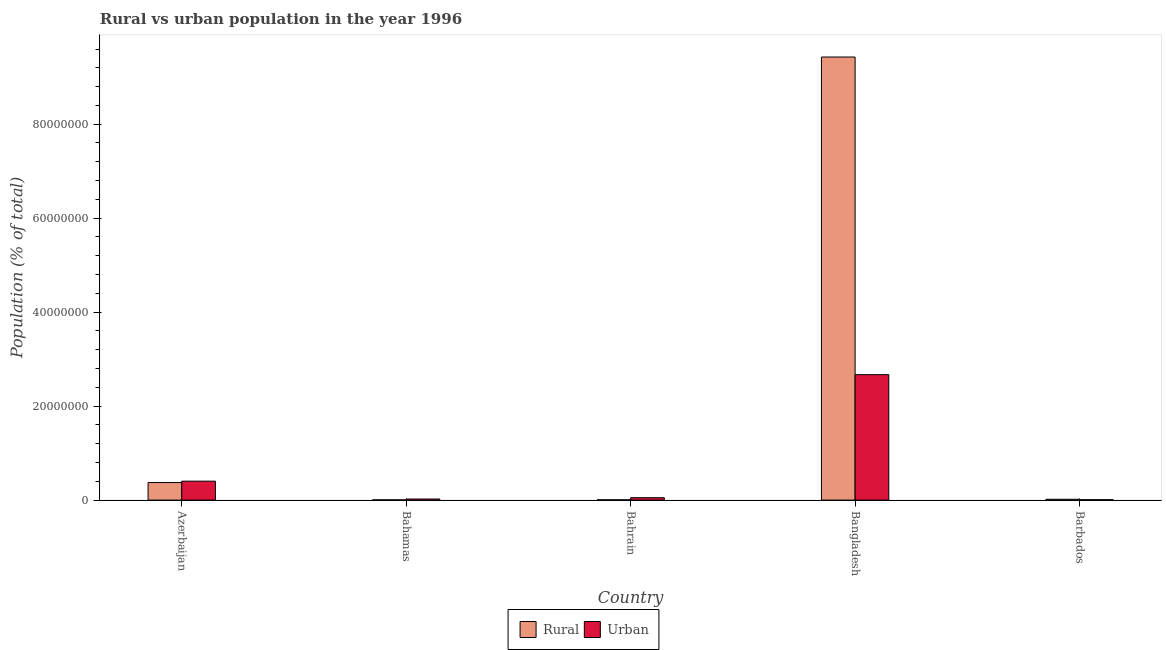How many different coloured bars are there?
Give a very brief answer. 2. How many groups of bars are there?
Provide a succinct answer. 5. Are the number of bars per tick equal to the number of legend labels?
Offer a very short reply. Yes. Are the number of bars on each tick of the X-axis equal?
Make the answer very short. Yes. How many bars are there on the 2nd tick from the left?
Your answer should be compact. 2. In how many cases, is the number of bars for a given country not equal to the number of legend labels?
Provide a short and direct response. 0. What is the urban population density in Azerbaijan?
Offer a terse response. 4.03e+06. Across all countries, what is the maximum rural population density?
Make the answer very short. 9.43e+07. Across all countries, what is the minimum urban population density?
Offer a very short reply. 8.88e+04. In which country was the urban population density minimum?
Provide a short and direct response. Barbados. What is the total rural population density in the graph?
Your answer should be very brief. 9.83e+07. What is the difference between the urban population density in Bahrain and that in Barbados?
Give a very brief answer. 4.24e+05. What is the difference between the rural population density in Bahamas and the urban population density in Barbados?
Ensure brevity in your answer.  -3.54e+04. What is the average rural population density per country?
Give a very brief answer. 1.97e+07. What is the difference between the urban population density and rural population density in Azerbaijan?
Keep it short and to the point. 2.94e+05. What is the ratio of the rural population density in Azerbaijan to that in Bangladesh?
Make the answer very short. 0.04. Is the rural population density in Bahamas less than that in Bangladesh?
Your response must be concise. Yes. Is the difference between the urban population density in Azerbaijan and Bangladesh greater than the difference between the rural population density in Azerbaijan and Bangladesh?
Your response must be concise. Yes. What is the difference between the highest and the second highest rural population density?
Provide a short and direct response. 9.06e+07. What is the difference between the highest and the lowest urban population density?
Keep it short and to the point. 2.66e+07. In how many countries, is the urban population density greater than the average urban population density taken over all countries?
Provide a succinct answer. 1. Is the sum of the rural population density in Azerbaijan and Barbados greater than the maximum urban population density across all countries?
Provide a short and direct response. No. What does the 1st bar from the left in Bangladesh represents?
Your answer should be compact. Rural. What does the 1st bar from the right in Azerbaijan represents?
Your answer should be very brief. Urban. Are all the bars in the graph horizontal?
Your answer should be compact. No. How many countries are there in the graph?
Offer a terse response. 5. Does the graph contain any zero values?
Your answer should be compact. No. How are the legend labels stacked?
Provide a short and direct response. Horizontal. What is the title of the graph?
Offer a very short reply. Rural vs urban population in the year 1996. Does "Largest city" appear as one of the legend labels in the graph?
Keep it short and to the point. No. What is the label or title of the X-axis?
Keep it short and to the point. Country. What is the label or title of the Y-axis?
Your answer should be very brief. Population (% of total). What is the Population (% of total) in Rural in Azerbaijan?
Keep it short and to the point. 3.73e+06. What is the Population (% of total) in Urban in Azerbaijan?
Make the answer very short. 4.03e+06. What is the Population (% of total) of Rural in Bahamas?
Make the answer very short. 5.34e+04. What is the Population (% of total) of Urban in Bahamas?
Make the answer very short. 2.30e+05. What is the Population (% of total) in Rural in Bahrain?
Your answer should be compact. 6.74e+04. What is the Population (% of total) in Urban in Bahrain?
Keep it short and to the point. 5.13e+05. What is the Population (% of total) in Rural in Bangladesh?
Offer a very short reply. 9.43e+07. What is the Population (% of total) in Urban in Bangladesh?
Your answer should be very brief. 2.67e+07. What is the Population (% of total) of Rural in Barbados?
Ensure brevity in your answer.  1.77e+05. What is the Population (% of total) in Urban in Barbados?
Make the answer very short. 8.88e+04. Across all countries, what is the maximum Population (% of total) in Rural?
Your answer should be compact. 9.43e+07. Across all countries, what is the maximum Population (% of total) of Urban?
Provide a succinct answer. 2.67e+07. Across all countries, what is the minimum Population (% of total) in Rural?
Make the answer very short. 5.34e+04. Across all countries, what is the minimum Population (% of total) of Urban?
Offer a terse response. 8.88e+04. What is the total Population (% of total) in Rural in the graph?
Offer a very short reply. 9.83e+07. What is the total Population (% of total) of Urban in the graph?
Make the answer very short. 3.16e+07. What is the difference between the Population (% of total) in Rural in Azerbaijan and that in Bahamas?
Keep it short and to the point. 3.68e+06. What is the difference between the Population (% of total) of Urban in Azerbaijan and that in Bahamas?
Offer a terse response. 3.80e+06. What is the difference between the Population (% of total) of Rural in Azerbaijan and that in Bahrain?
Keep it short and to the point. 3.67e+06. What is the difference between the Population (% of total) in Urban in Azerbaijan and that in Bahrain?
Your response must be concise. 3.52e+06. What is the difference between the Population (% of total) in Rural in Azerbaijan and that in Bangladesh?
Your answer should be very brief. -9.06e+07. What is the difference between the Population (% of total) of Urban in Azerbaijan and that in Bangladesh?
Provide a succinct answer. -2.27e+07. What is the difference between the Population (% of total) of Rural in Azerbaijan and that in Barbados?
Your answer should be very brief. 3.56e+06. What is the difference between the Population (% of total) of Urban in Azerbaijan and that in Barbados?
Your answer should be very brief. 3.94e+06. What is the difference between the Population (% of total) of Rural in Bahamas and that in Bahrain?
Offer a very short reply. -1.39e+04. What is the difference between the Population (% of total) of Urban in Bahamas and that in Bahrain?
Your response must be concise. -2.82e+05. What is the difference between the Population (% of total) of Rural in Bahamas and that in Bangladesh?
Provide a succinct answer. -9.42e+07. What is the difference between the Population (% of total) in Urban in Bahamas and that in Bangladesh?
Keep it short and to the point. -2.65e+07. What is the difference between the Population (% of total) in Rural in Bahamas and that in Barbados?
Give a very brief answer. -1.24e+05. What is the difference between the Population (% of total) of Urban in Bahamas and that in Barbados?
Offer a very short reply. 1.42e+05. What is the difference between the Population (% of total) in Rural in Bahrain and that in Bangladesh?
Provide a succinct answer. -9.42e+07. What is the difference between the Population (% of total) of Urban in Bahrain and that in Bangladesh?
Provide a short and direct response. -2.62e+07. What is the difference between the Population (% of total) in Rural in Bahrain and that in Barbados?
Your answer should be compact. -1.10e+05. What is the difference between the Population (% of total) of Urban in Bahrain and that in Barbados?
Offer a very short reply. 4.24e+05. What is the difference between the Population (% of total) of Rural in Bangladesh and that in Barbados?
Your response must be concise. 9.41e+07. What is the difference between the Population (% of total) in Urban in Bangladesh and that in Barbados?
Your answer should be compact. 2.66e+07. What is the difference between the Population (% of total) of Rural in Azerbaijan and the Population (% of total) of Urban in Bahamas?
Your answer should be very brief. 3.50e+06. What is the difference between the Population (% of total) in Rural in Azerbaijan and the Population (% of total) in Urban in Bahrain?
Give a very brief answer. 3.22e+06. What is the difference between the Population (% of total) in Rural in Azerbaijan and the Population (% of total) in Urban in Bangladesh?
Keep it short and to the point. -2.30e+07. What is the difference between the Population (% of total) of Rural in Azerbaijan and the Population (% of total) of Urban in Barbados?
Keep it short and to the point. 3.65e+06. What is the difference between the Population (% of total) of Rural in Bahamas and the Population (% of total) of Urban in Bahrain?
Offer a very short reply. -4.59e+05. What is the difference between the Population (% of total) of Rural in Bahamas and the Population (% of total) of Urban in Bangladesh?
Your answer should be compact. -2.66e+07. What is the difference between the Population (% of total) of Rural in Bahamas and the Population (% of total) of Urban in Barbados?
Provide a short and direct response. -3.54e+04. What is the difference between the Population (% of total) of Rural in Bahrain and the Population (% of total) of Urban in Bangladesh?
Ensure brevity in your answer.  -2.66e+07. What is the difference between the Population (% of total) of Rural in Bahrain and the Population (% of total) of Urban in Barbados?
Give a very brief answer. -2.14e+04. What is the difference between the Population (% of total) of Rural in Bangladesh and the Population (% of total) of Urban in Barbados?
Make the answer very short. 9.42e+07. What is the average Population (% of total) of Rural per country?
Your answer should be compact. 1.97e+07. What is the average Population (% of total) in Urban per country?
Ensure brevity in your answer.  6.31e+06. What is the difference between the Population (% of total) in Rural and Population (% of total) in Urban in Azerbaijan?
Your answer should be very brief. -2.94e+05. What is the difference between the Population (% of total) in Rural and Population (% of total) in Urban in Bahamas?
Make the answer very short. -1.77e+05. What is the difference between the Population (% of total) of Rural and Population (% of total) of Urban in Bahrain?
Offer a terse response. -4.45e+05. What is the difference between the Population (% of total) in Rural and Population (% of total) in Urban in Bangladesh?
Your response must be concise. 6.76e+07. What is the difference between the Population (% of total) in Rural and Population (% of total) in Urban in Barbados?
Provide a short and direct response. 8.84e+04. What is the ratio of the Population (% of total) of Rural in Azerbaijan to that in Bahamas?
Give a very brief answer. 69.92. What is the ratio of the Population (% of total) of Urban in Azerbaijan to that in Bahamas?
Your response must be concise. 17.49. What is the ratio of the Population (% of total) in Rural in Azerbaijan to that in Bahrain?
Keep it short and to the point. 55.45. What is the ratio of the Population (% of total) of Urban in Azerbaijan to that in Bahrain?
Give a very brief answer. 7.86. What is the ratio of the Population (% of total) of Rural in Azerbaijan to that in Bangladesh?
Ensure brevity in your answer.  0.04. What is the ratio of the Population (% of total) of Urban in Azerbaijan to that in Bangladesh?
Give a very brief answer. 0.15. What is the ratio of the Population (% of total) of Rural in Azerbaijan to that in Barbados?
Make the answer very short. 21.08. What is the ratio of the Population (% of total) of Urban in Azerbaijan to that in Barbados?
Keep it short and to the point. 45.37. What is the ratio of the Population (% of total) in Rural in Bahamas to that in Bahrain?
Your answer should be very brief. 0.79. What is the ratio of the Population (% of total) in Urban in Bahamas to that in Bahrain?
Ensure brevity in your answer.  0.45. What is the ratio of the Population (% of total) in Rural in Bahamas to that in Bangladesh?
Provide a succinct answer. 0. What is the ratio of the Population (% of total) in Urban in Bahamas to that in Bangladesh?
Your answer should be very brief. 0.01. What is the ratio of the Population (% of total) of Rural in Bahamas to that in Barbados?
Give a very brief answer. 0.3. What is the ratio of the Population (% of total) in Urban in Bahamas to that in Barbados?
Your response must be concise. 2.59. What is the ratio of the Population (% of total) of Rural in Bahrain to that in Bangladesh?
Make the answer very short. 0. What is the ratio of the Population (% of total) of Urban in Bahrain to that in Bangladesh?
Provide a short and direct response. 0.02. What is the ratio of the Population (% of total) in Rural in Bahrain to that in Barbados?
Offer a very short reply. 0.38. What is the ratio of the Population (% of total) of Urban in Bahrain to that in Barbados?
Your answer should be compact. 5.77. What is the ratio of the Population (% of total) in Rural in Bangladesh to that in Barbados?
Ensure brevity in your answer.  532.27. What is the ratio of the Population (% of total) in Urban in Bangladesh to that in Barbados?
Give a very brief answer. 300.66. What is the difference between the highest and the second highest Population (% of total) in Rural?
Offer a terse response. 9.06e+07. What is the difference between the highest and the second highest Population (% of total) in Urban?
Your answer should be compact. 2.27e+07. What is the difference between the highest and the lowest Population (% of total) of Rural?
Make the answer very short. 9.42e+07. What is the difference between the highest and the lowest Population (% of total) of Urban?
Give a very brief answer. 2.66e+07. 